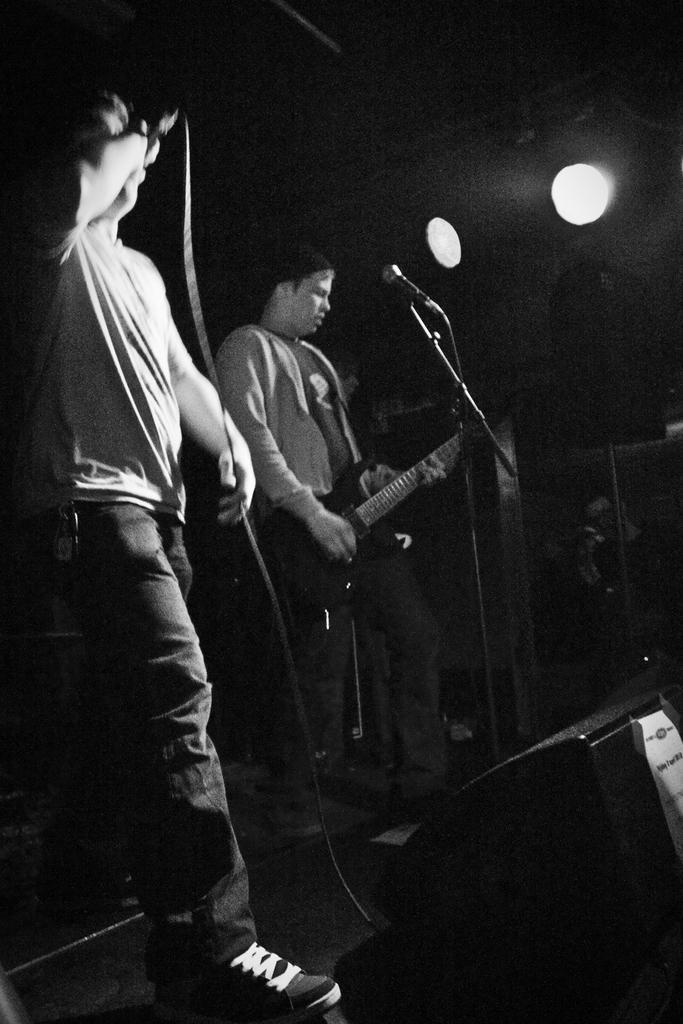Can you describe this image briefly? The person in the right is playing guitar in front of a mic and the person in the left is standing and singing in front of a mic. 